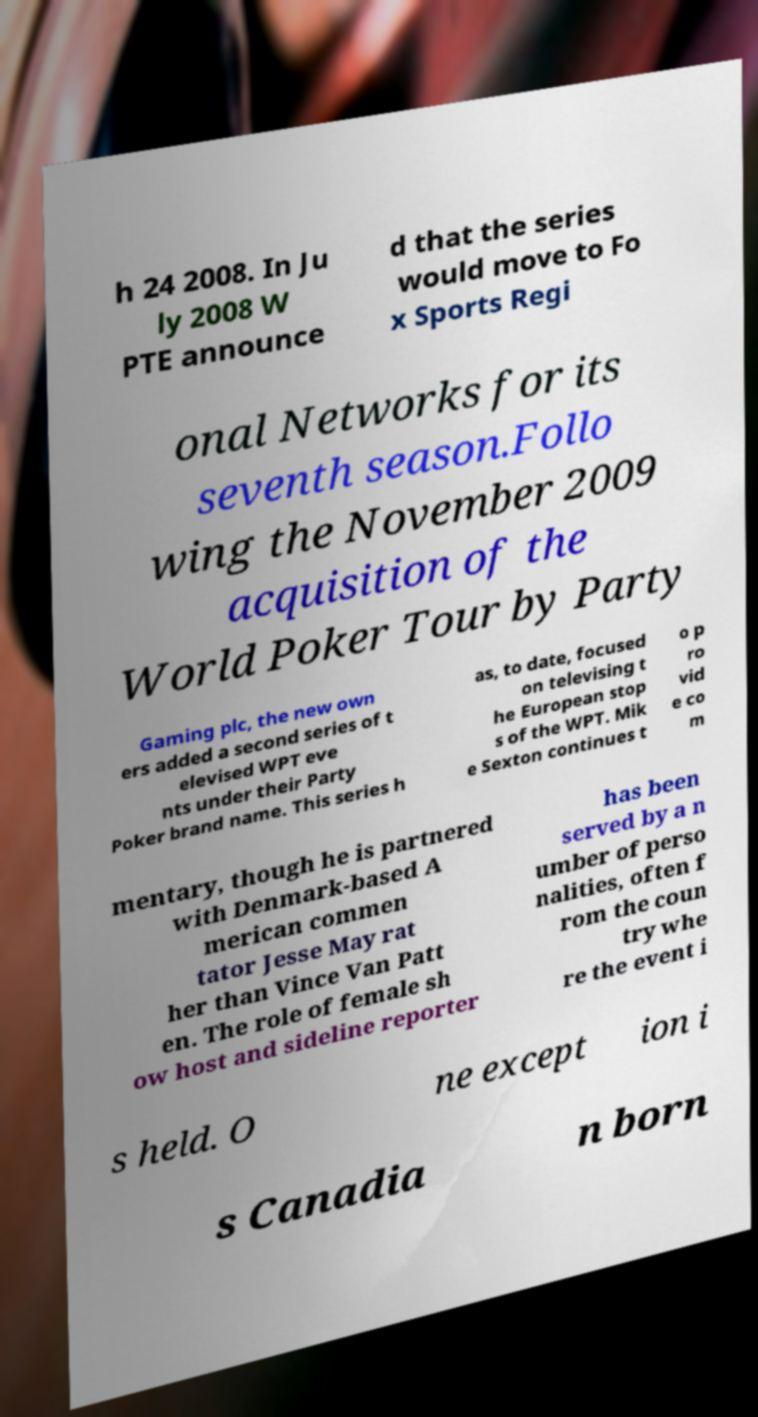For documentation purposes, I need the text within this image transcribed. Could you provide that? h 24 2008. In Ju ly 2008 W PTE announce d that the series would move to Fo x Sports Regi onal Networks for its seventh season.Follo wing the November 2009 acquisition of the World Poker Tour by Party Gaming plc, the new own ers added a second series of t elevised WPT eve nts under their Party Poker brand name. This series h as, to date, focused on televising t he European stop s of the WPT. Mik e Sexton continues t o p ro vid e co m mentary, though he is partnered with Denmark-based A merican commen tator Jesse May rat her than Vince Van Patt en. The role of female sh ow host and sideline reporter has been served by a n umber of perso nalities, often f rom the coun try whe re the event i s held. O ne except ion i s Canadia n born 